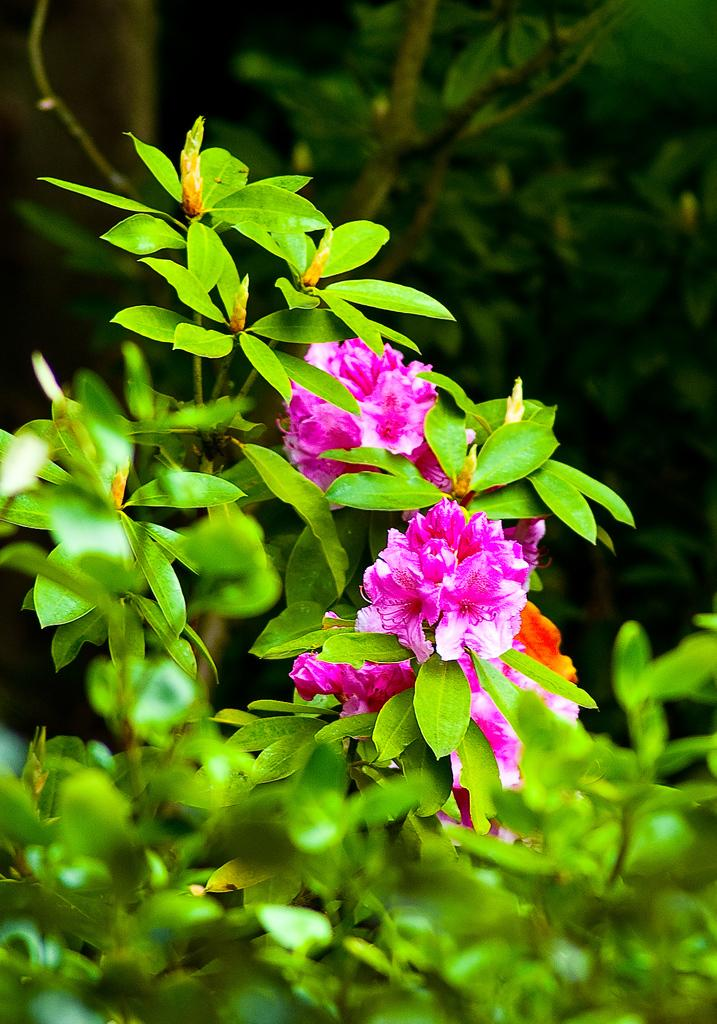What color are the flowers in the image? The flowers in the image are purple colored. What type of plant do the flowers belong to? The flowers belong to a plant. How is the focus of the image? The bottom of the image is slightly blurred. What is the color of the background in the image? The background of the image is dark. Are there any other plants visible in the image? Yes, there are a few more plants visible in the background. Can you tell me the price of the stocking shown in the image? There is no stocking present in the image, so it is not possible to determine its price. 